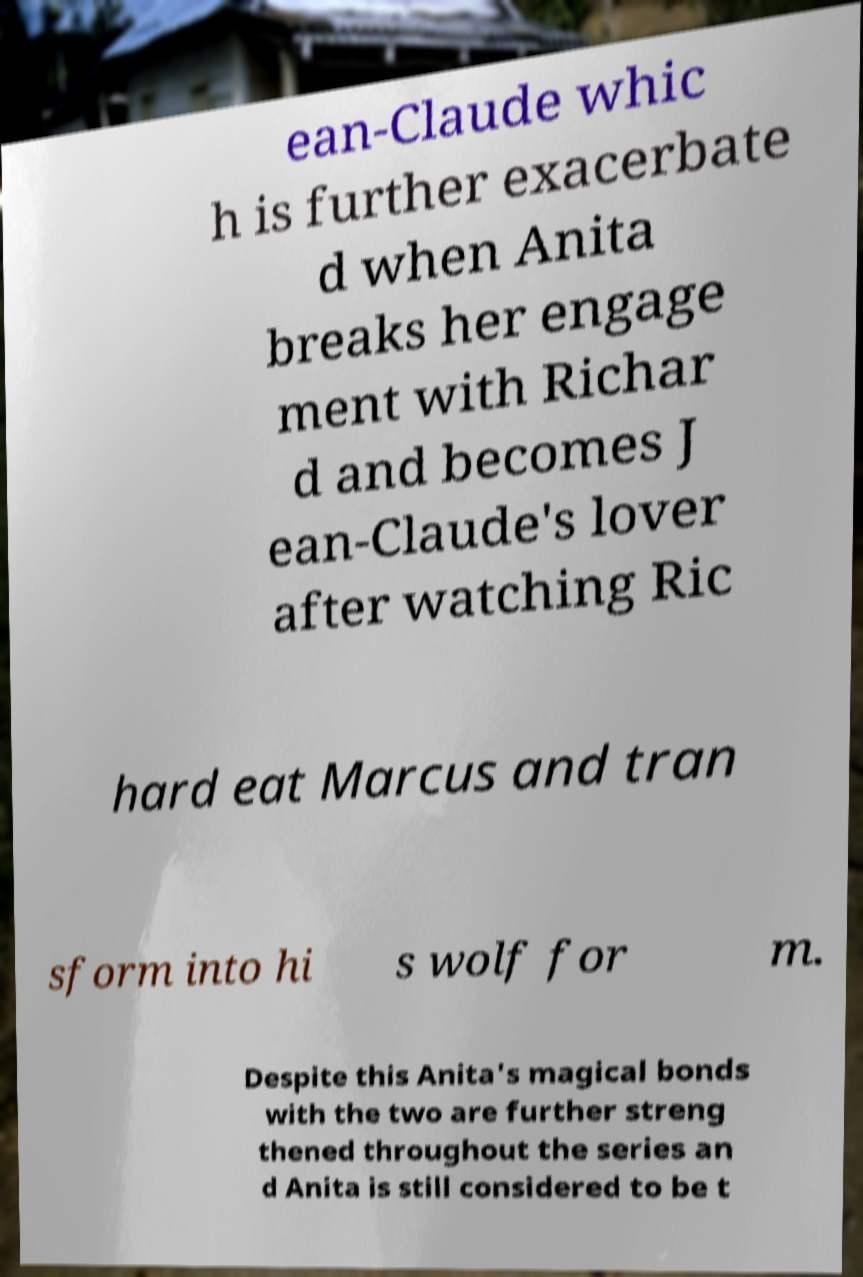Please identify and transcribe the text found in this image. ean-Claude whic h is further exacerbate d when Anita breaks her engage ment with Richar d and becomes J ean-Claude's lover after watching Ric hard eat Marcus and tran sform into hi s wolf for m. Despite this Anita's magical bonds with the two are further streng thened throughout the series an d Anita is still considered to be t 